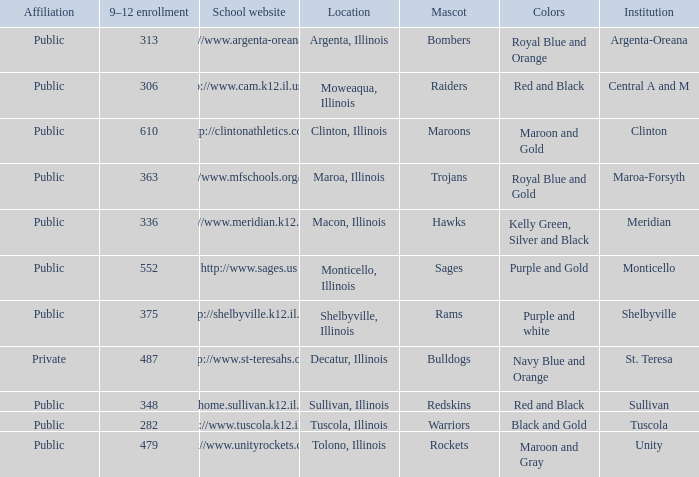What's the website of the school in Macon, Illinois? Http://www.meridian.k12.il.us/. 